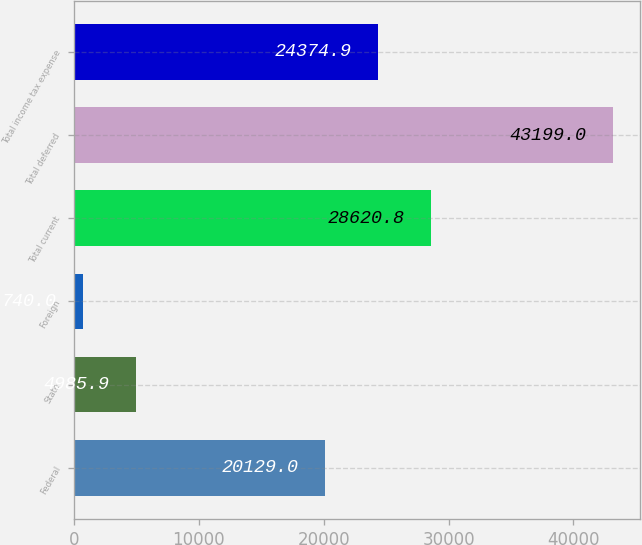Convert chart to OTSL. <chart><loc_0><loc_0><loc_500><loc_500><bar_chart><fcel>Federal<fcel>State<fcel>Foreign<fcel>Total current<fcel>Total deferred<fcel>Total income tax expense<nl><fcel>20129<fcel>4985.9<fcel>740<fcel>28620.8<fcel>43199<fcel>24374.9<nl></chart> 